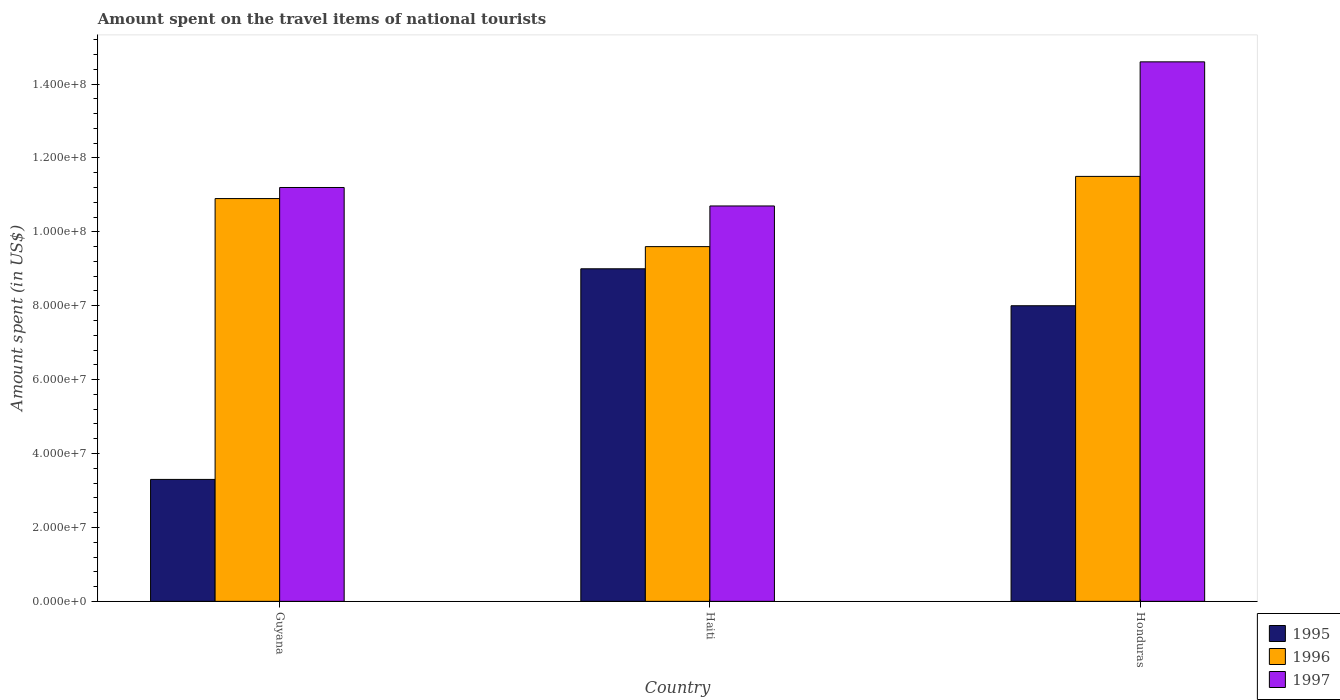Are the number of bars on each tick of the X-axis equal?
Provide a short and direct response. Yes. How many bars are there on the 3rd tick from the left?
Offer a very short reply. 3. How many bars are there on the 3rd tick from the right?
Provide a short and direct response. 3. What is the label of the 2nd group of bars from the left?
Your response must be concise. Haiti. In how many cases, is the number of bars for a given country not equal to the number of legend labels?
Make the answer very short. 0. What is the amount spent on the travel items of national tourists in 1997 in Honduras?
Ensure brevity in your answer.  1.46e+08. Across all countries, what is the maximum amount spent on the travel items of national tourists in 1997?
Provide a short and direct response. 1.46e+08. Across all countries, what is the minimum amount spent on the travel items of national tourists in 1995?
Keep it short and to the point. 3.30e+07. In which country was the amount spent on the travel items of national tourists in 1996 maximum?
Give a very brief answer. Honduras. In which country was the amount spent on the travel items of national tourists in 1995 minimum?
Your answer should be compact. Guyana. What is the total amount spent on the travel items of national tourists in 1997 in the graph?
Give a very brief answer. 3.65e+08. What is the difference between the amount spent on the travel items of national tourists in 1996 in Guyana and that in Honduras?
Give a very brief answer. -6.00e+06. What is the difference between the amount spent on the travel items of national tourists in 1996 in Guyana and the amount spent on the travel items of national tourists in 1997 in Honduras?
Your answer should be very brief. -3.70e+07. What is the average amount spent on the travel items of national tourists in 1995 per country?
Offer a very short reply. 6.77e+07. What is the difference between the amount spent on the travel items of national tourists of/in 1995 and amount spent on the travel items of national tourists of/in 1996 in Honduras?
Ensure brevity in your answer.  -3.50e+07. In how many countries, is the amount spent on the travel items of national tourists in 1995 greater than 136000000 US$?
Give a very brief answer. 0. What is the ratio of the amount spent on the travel items of national tourists in 1997 in Guyana to that in Haiti?
Keep it short and to the point. 1.05. What is the difference between the highest and the lowest amount spent on the travel items of national tourists in 1997?
Keep it short and to the point. 3.90e+07. In how many countries, is the amount spent on the travel items of national tourists in 1996 greater than the average amount spent on the travel items of national tourists in 1996 taken over all countries?
Provide a succinct answer. 2. What does the 1st bar from the left in Haiti represents?
Offer a terse response. 1995. Is it the case that in every country, the sum of the amount spent on the travel items of national tourists in 1995 and amount spent on the travel items of national tourists in 1997 is greater than the amount spent on the travel items of national tourists in 1996?
Keep it short and to the point. Yes. How many bars are there?
Give a very brief answer. 9. Are all the bars in the graph horizontal?
Your answer should be compact. No. How many countries are there in the graph?
Give a very brief answer. 3. Are the values on the major ticks of Y-axis written in scientific E-notation?
Make the answer very short. Yes. How are the legend labels stacked?
Provide a short and direct response. Vertical. What is the title of the graph?
Your answer should be compact. Amount spent on the travel items of national tourists. What is the label or title of the Y-axis?
Your response must be concise. Amount spent (in US$). What is the Amount spent (in US$) in 1995 in Guyana?
Your answer should be very brief. 3.30e+07. What is the Amount spent (in US$) in 1996 in Guyana?
Ensure brevity in your answer.  1.09e+08. What is the Amount spent (in US$) of 1997 in Guyana?
Ensure brevity in your answer.  1.12e+08. What is the Amount spent (in US$) in 1995 in Haiti?
Your response must be concise. 9.00e+07. What is the Amount spent (in US$) of 1996 in Haiti?
Ensure brevity in your answer.  9.60e+07. What is the Amount spent (in US$) in 1997 in Haiti?
Keep it short and to the point. 1.07e+08. What is the Amount spent (in US$) of 1995 in Honduras?
Your answer should be compact. 8.00e+07. What is the Amount spent (in US$) of 1996 in Honduras?
Ensure brevity in your answer.  1.15e+08. What is the Amount spent (in US$) of 1997 in Honduras?
Ensure brevity in your answer.  1.46e+08. Across all countries, what is the maximum Amount spent (in US$) in 1995?
Provide a succinct answer. 9.00e+07. Across all countries, what is the maximum Amount spent (in US$) in 1996?
Your answer should be compact. 1.15e+08. Across all countries, what is the maximum Amount spent (in US$) of 1997?
Offer a very short reply. 1.46e+08. Across all countries, what is the minimum Amount spent (in US$) in 1995?
Your answer should be compact. 3.30e+07. Across all countries, what is the minimum Amount spent (in US$) of 1996?
Make the answer very short. 9.60e+07. Across all countries, what is the minimum Amount spent (in US$) in 1997?
Your response must be concise. 1.07e+08. What is the total Amount spent (in US$) in 1995 in the graph?
Your answer should be compact. 2.03e+08. What is the total Amount spent (in US$) in 1996 in the graph?
Provide a succinct answer. 3.20e+08. What is the total Amount spent (in US$) in 1997 in the graph?
Keep it short and to the point. 3.65e+08. What is the difference between the Amount spent (in US$) of 1995 in Guyana and that in Haiti?
Give a very brief answer. -5.70e+07. What is the difference between the Amount spent (in US$) in 1996 in Guyana and that in Haiti?
Give a very brief answer. 1.30e+07. What is the difference between the Amount spent (in US$) in 1997 in Guyana and that in Haiti?
Offer a terse response. 5.00e+06. What is the difference between the Amount spent (in US$) in 1995 in Guyana and that in Honduras?
Offer a very short reply. -4.70e+07. What is the difference between the Amount spent (in US$) in 1996 in Guyana and that in Honduras?
Provide a succinct answer. -6.00e+06. What is the difference between the Amount spent (in US$) of 1997 in Guyana and that in Honduras?
Keep it short and to the point. -3.40e+07. What is the difference between the Amount spent (in US$) in 1995 in Haiti and that in Honduras?
Your response must be concise. 1.00e+07. What is the difference between the Amount spent (in US$) in 1996 in Haiti and that in Honduras?
Offer a terse response. -1.90e+07. What is the difference between the Amount spent (in US$) in 1997 in Haiti and that in Honduras?
Make the answer very short. -3.90e+07. What is the difference between the Amount spent (in US$) in 1995 in Guyana and the Amount spent (in US$) in 1996 in Haiti?
Your answer should be very brief. -6.30e+07. What is the difference between the Amount spent (in US$) in 1995 in Guyana and the Amount spent (in US$) in 1997 in Haiti?
Your answer should be compact. -7.40e+07. What is the difference between the Amount spent (in US$) of 1995 in Guyana and the Amount spent (in US$) of 1996 in Honduras?
Your answer should be very brief. -8.20e+07. What is the difference between the Amount spent (in US$) of 1995 in Guyana and the Amount spent (in US$) of 1997 in Honduras?
Give a very brief answer. -1.13e+08. What is the difference between the Amount spent (in US$) of 1996 in Guyana and the Amount spent (in US$) of 1997 in Honduras?
Keep it short and to the point. -3.70e+07. What is the difference between the Amount spent (in US$) in 1995 in Haiti and the Amount spent (in US$) in 1996 in Honduras?
Make the answer very short. -2.50e+07. What is the difference between the Amount spent (in US$) of 1995 in Haiti and the Amount spent (in US$) of 1997 in Honduras?
Offer a very short reply. -5.60e+07. What is the difference between the Amount spent (in US$) of 1996 in Haiti and the Amount spent (in US$) of 1997 in Honduras?
Your answer should be very brief. -5.00e+07. What is the average Amount spent (in US$) of 1995 per country?
Your response must be concise. 6.77e+07. What is the average Amount spent (in US$) of 1996 per country?
Offer a very short reply. 1.07e+08. What is the average Amount spent (in US$) in 1997 per country?
Ensure brevity in your answer.  1.22e+08. What is the difference between the Amount spent (in US$) of 1995 and Amount spent (in US$) of 1996 in Guyana?
Make the answer very short. -7.60e+07. What is the difference between the Amount spent (in US$) in 1995 and Amount spent (in US$) in 1997 in Guyana?
Offer a terse response. -7.90e+07. What is the difference between the Amount spent (in US$) of 1995 and Amount spent (in US$) of 1996 in Haiti?
Give a very brief answer. -6.00e+06. What is the difference between the Amount spent (in US$) of 1995 and Amount spent (in US$) of 1997 in Haiti?
Your answer should be very brief. -1.70e+07. What is the difference between the Amount spent (in US$) of 1996 and Amount spent (in US$) of 1997 in Haiti?
Offer a terse response. -1.10e+07. What is the difference between the Amount spent (in US$) in 1995 and Amount spent (in US$) in 1996 in Honduras?
Your response must be concise. -3.50e+07. What is the difference between the Amount spent (in US$) in 1995 and Amount spent (in US$) in 1997 in Honduras?
Provide a short and direct response. -6.60e+07. What is the difference between the Amount spent (in US$) in 1996 and Amount spent (in US$) in 1997 in Honduras?
Give a very brief answer. -3.10e+07. What is the ratio of the Amount spent (in US$) in 1995 in Guyana to that in Haiti?
Make the answer very short. 0.37. What is the ratio of the Amount spent (in US$) in 1996 in Guyana to that in Haiti?
Provide a succinct answer. 1.14. What is the ratio of the Amount spent (in US$) in 1997 in Guyana to that in Haiti?
Provide a short and direct response. 1.05. What is the ratio of the Amount spent (in US$) in 1995 in Guyana to that in Honduras?
Provide a succinct answer. 0.41. What is the ratio of the Amount spent (in US$) of 1996 in Guyana to that in Honduras?
Make the answer very short. 0.95. What is the ratio of the Amount spent (in US$) in 1997 in Guyana to that in Honduras?
Provide a succinct answer. 0.77. What is the ratio of the Amount spent (in US$) in 1995 in Haiti to that in Honduras?
Offer a terse response. 1.12. What is the ratio of the Amount spent (in US$) of 1996 in Haiti to that in Honduras?
Provide a short and direct response. 0.83. What is the ratio of the Amount spent (in US$) in 1997 in Haiti to that in Honduras?
Make the answer very short. 0.73. What is the difference between the highest and the second highest Amount spent (in US$) of 1995?
Provide a short and direct response. 1.00e+07. What is the difference between the highest and the second highest Amount spent (in US$) of 1996?
Your response must be concise. 6.00e+06. What is the difference between the highest and the second highest Amount spent (in US$) in 1997?
Provide a succinct answer. 3.40e+07. What is the difference between the highest and the lowest Amount spent (in US$) in 1995?
Provide a short and direct response. 5.70e+07. What is the difference between the highest and the lowest Amount spent (in US$) in 1996?
Offer a terse response. 1.90e+07. What is the difference between the highest and the lowest Amount spent (in US$) of 1997?
Give a very brief answer. 3.90e+07. 